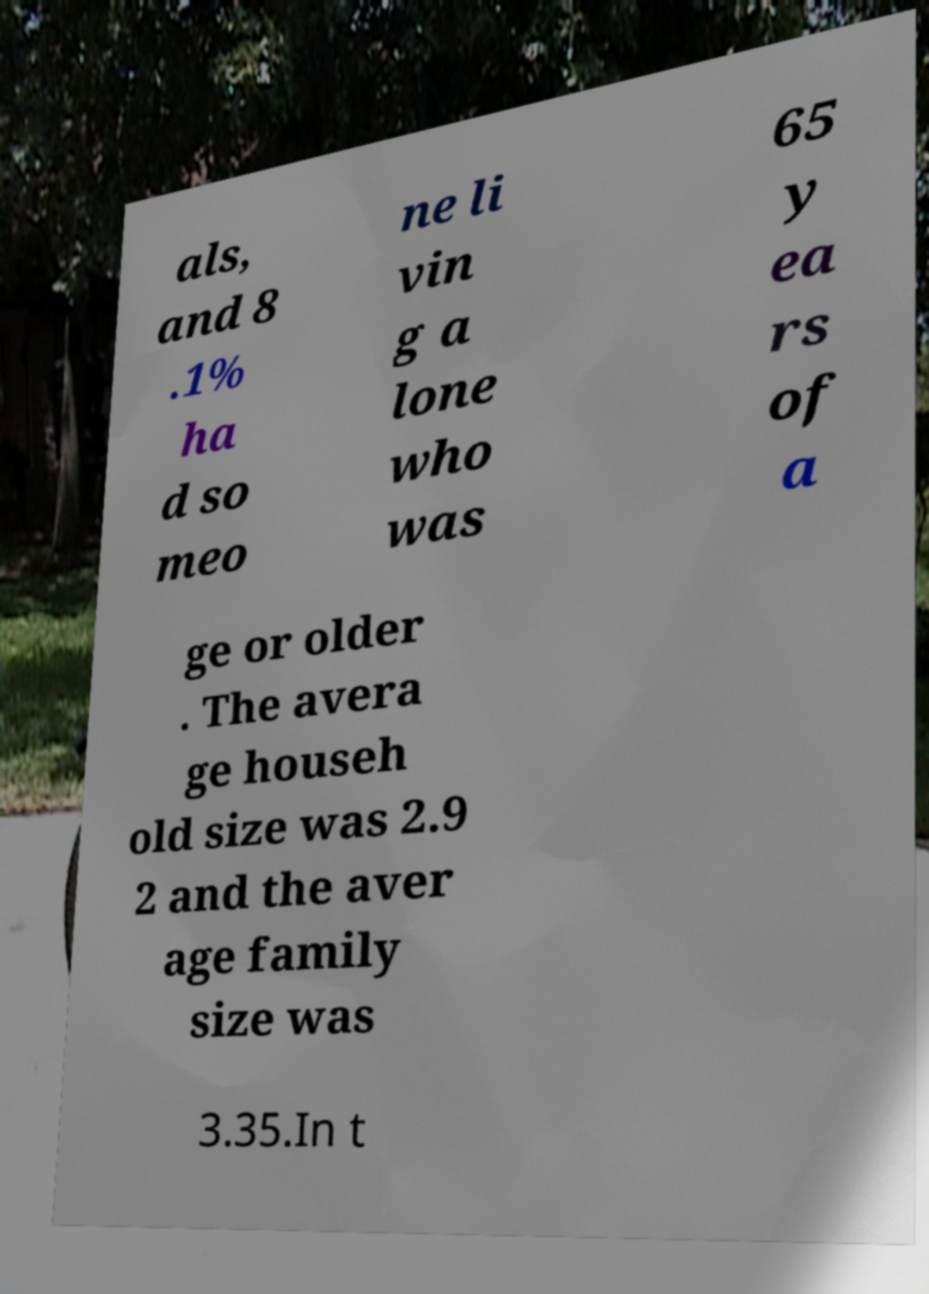Can you read and provide the text displayed in the image?This photo seems to have some interesting text. Can you extract and type it out for me? als, and 8 .1% ha d so meo ne li vin g a lone who was 65 y ea rs of a ge or older . The avera ge househ old size was 2.9 2 and the aver age family size was 3.35.In t 